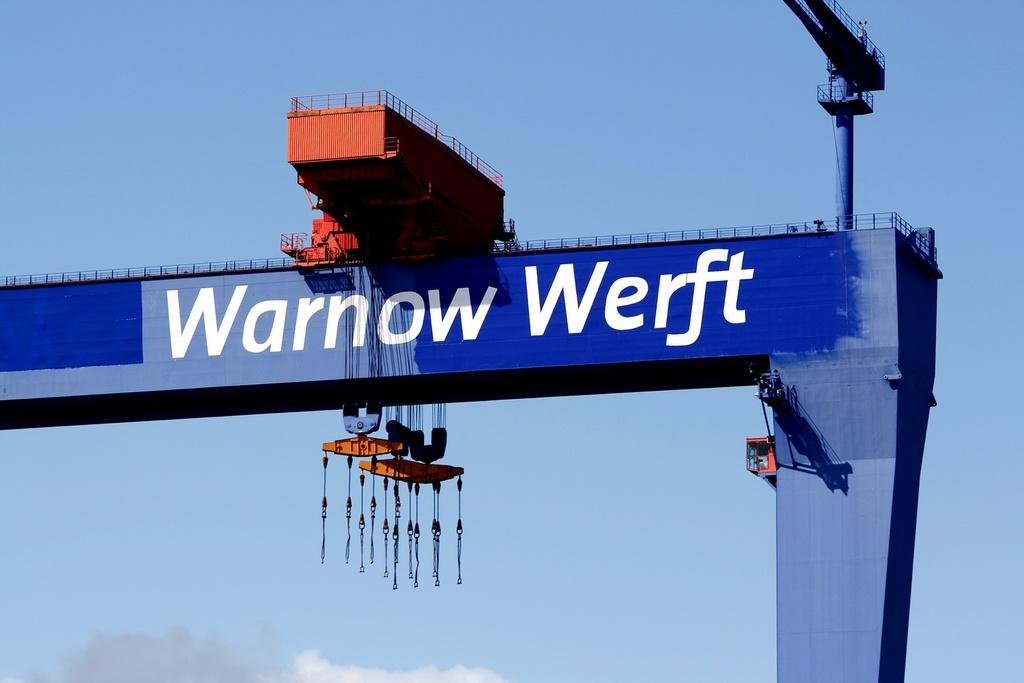<image>
Provide a brief description of the given image. The blue top side of a large crane that reads Warnow werft on it. 